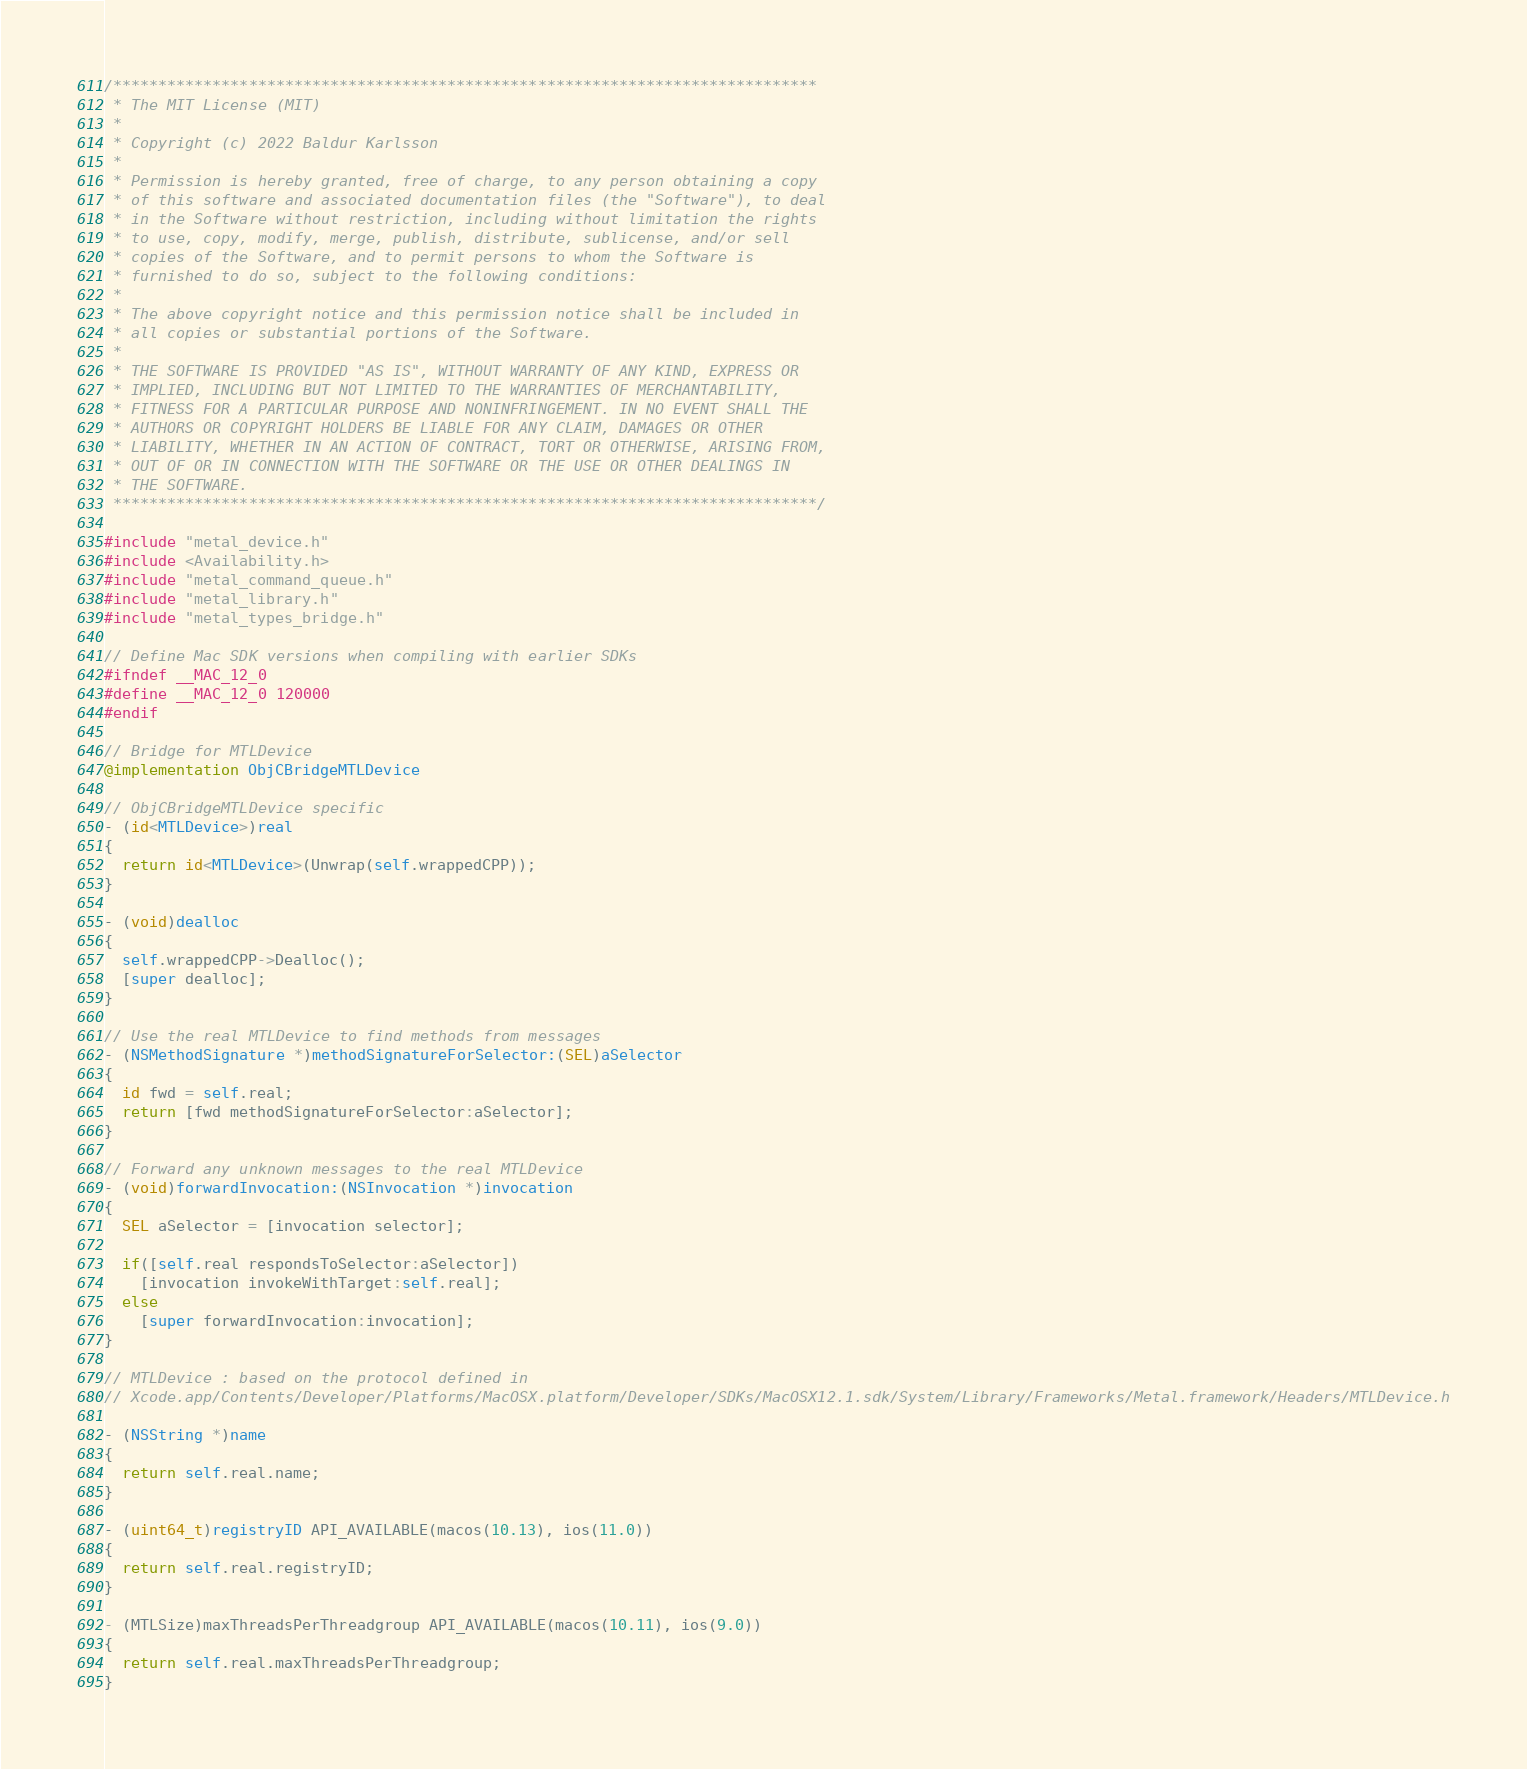<code> <loc_0><loc_0><loc_500><loc_500><_ObjectiveC_>/******************************************************************************
 * The MIT License (MIT)
 *
 * Copyright (c) 2022 Baldur Karlsson
 *
 * Permission is hereby granted, free of charge, to any person obtaining a copy
 * of this software and associated documentation files (the "Software"), to deal
 * in the Software without restriction, including without limitation the rights
 * to use, copy, modify, merge, publish, distribute, sublicense, and/or sell
 * copies of the Software, and to permit persons to whom the Software is
 * furnished to do so, subject to the following conditions:
 *
 * The above copyright notice and this permission notice shall be included in
 * all copies or substantial portions of the Software.
 *
 * THE SOFTWARE IS PROVIDED "AS IS", WITHOUT WARRANTY OF ANY KIND, EXPRESS OR
 * IMPLIED, INCLUDING BUT NOT LIMITED TO THE WARRANTIES OF MERCHANTABILITY,
 * FITNESS FOR A PARTICULAR PURPOSE AND NONINFRINGEMENT. IN NO EVENT SHALL THE
 * AUTHORS OR COPYRIGHT HOLDERS BE LIABLE FOR ANY CLAIM, DAMAGES OR OTHER
 * LIABILITY, WHETHER IN AN ACTION OF CONTRACT, TORT OR OTHERWISE, ARISING FROM,
 * OUT OF OR IN CONNECTION WITH THE SOFTWARE OR THE USE OR OTHER DEALINGS IN
 * THE SOFTWARE.
 ******************************************************************************/

#include "metal_device.h"
#include <Availability.h>
#include "metal_command_queue.h"
#include "metal_library.h"
#include "metal_types_bridge.h"

// Define Mac SDK versions when compiling with earlier SDKs
#ifndef __MAC_12_0
#define __MAC_12_0 120000
#endif

// Bridge for MTLDevice
@implementation ObjCBridgeMTLDevice

// ObjCBridgeMTLDevice specific
- (id<MTLDevice>)real
{
  return id<MTLDevice>(Unwrap(self.wrappedCPP));
}

- (void)dealloc
{
  self.wrappedCPP->Dealloc();
  [super dealloc];
}

// Use the real MTLDevice to find methods from messages
- (NSMethodSignature *)methodSignatureForSelector:(SEL)aSelector
{
  id fwd = self.real;
  return [fwd methodSignatureForSelector:aSelector];
}

// Forward any unknown messages to the real MTLDevice
- (void)forwardInvocation:(NSInvocation *)invocation
{
  SEL aSelector = [invocation selector];

  if([self.real respondsToSelector:aSelector])
    [invocation invokeWithTarget:self.real];
  else
    [super forwardInvocation:invocation];
}

// MTLDevice : based on the protocol defined in
// Xcode.app/Contents/Developer/Platforms/MacOSX.platform/Developer/SDKs/MacOSX12.1.sdk/System/Library/Frameworks/Metal.framework/Headers/MTLDevice.h

- (NSString *)name
{
  return self.real.name;
}

- (uint64_t)registryID API_AVAILABLE(macos(10.13), ios(11.0))
{
  return self.real.registryID;
}

- (MTLSize)maxThreadsPerThreadgroup API_AVAILABLE(macos(10.11), ios(9.0))
{
  return self.real.maxThreadsPerThreadgroup;
}
</code> 